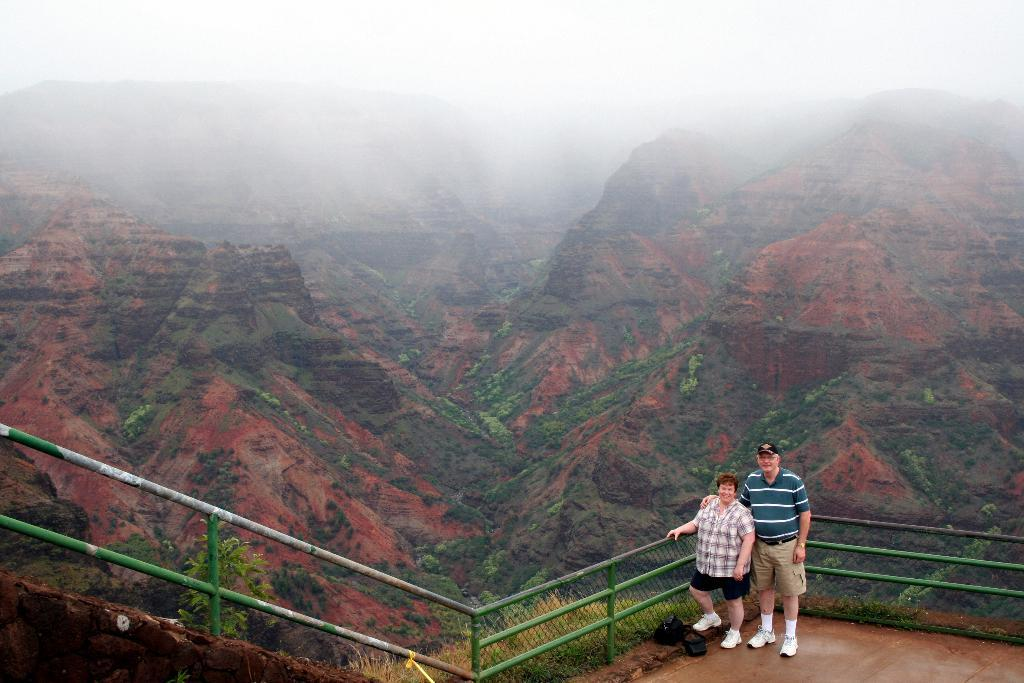How many people are present in the image? There are two persons standing in the image. What objects can be seen in the image besides the people? There are iron rods, a net, trees, and hills visible in the image. What is visible in the background of the image? The sky is visible in the background of the image. What type of soda is being served in the image? There is no soda present in the image. Can you tell me what prose is being read by the persons in the image? There is no indication of any reading material or prose in the image. 